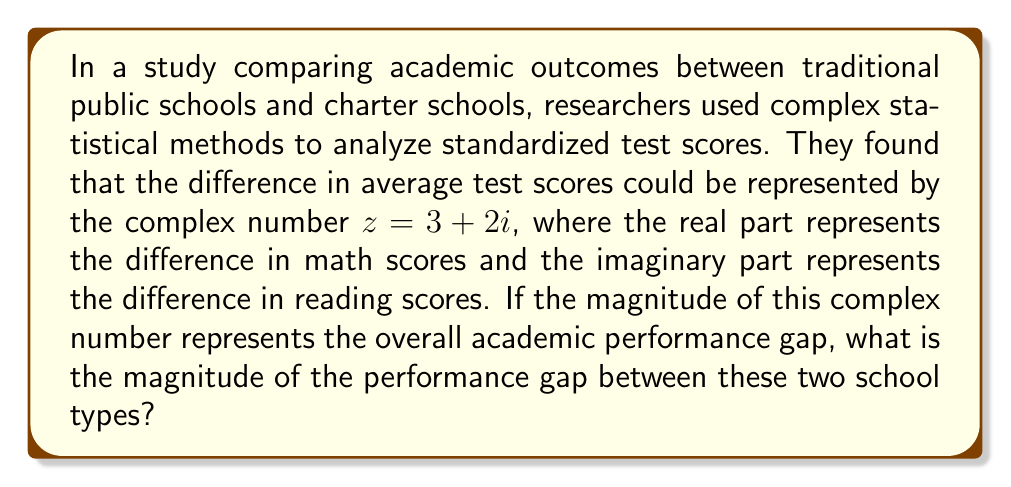Can you answer this question? To solve this problem, we need to calculate the magnitude of the complex number $z = 3 + 2i$. The magnitude of a complex number is also known as its absolute value or modulus.

For a complex number $z = a + bi$, the magnitude is given by the formula:

$$|z| = \sqrt{a^2 + b^2}$$

Where:
$a$ is the real part
$b$ is the imaginary part

In our case:
$a = 3$ (difference in math scores)
$b = 2$ (difference in reading scores)

Let's substitute these values into the formula:

$$|z| = \sqrt{3^2 + 2^2}$$

Now, let's calculate:

$$|z| = \sqrt{9 + 4}$$
$$|z| = \sqrt{13}$$

The square root of 13 cannot be simplified further, so this is our final answer.

This result means that the overall academic performance gap between traditional public schools and charter schools, considering both math and reading scores, is $\sqrt{13}$ units.
Answer: $\sqrt{13}$ 